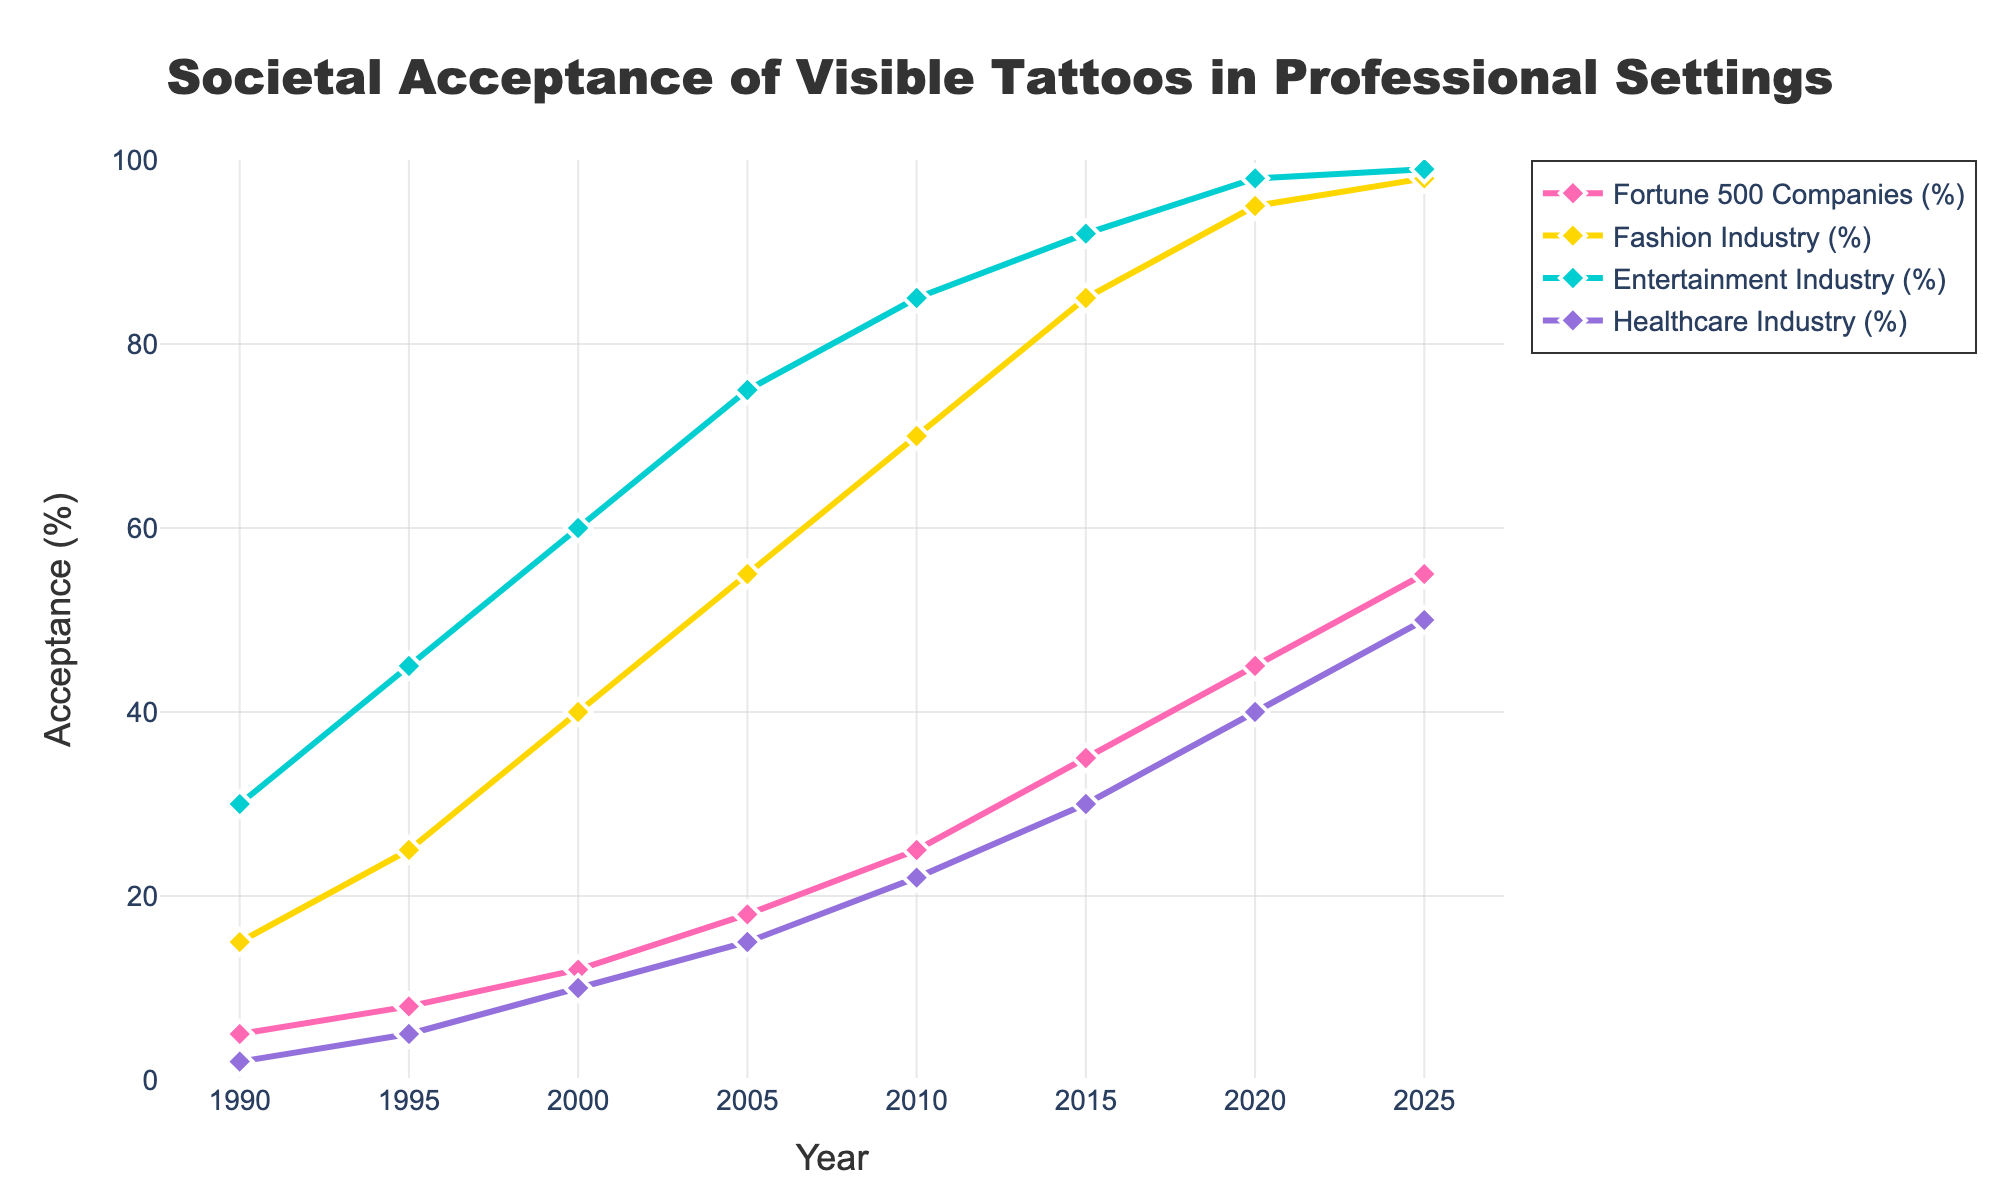what percentage of Fortune 500 companies accepted visible tattoos in 2005? According to the figure, the percentage of Fortune 500 companies accepting visible tattoos in 2005 can be read directly from the data point on the curve corresponding to that year.
Answer: 18% How much did the acceptance of visible tattoos in the entertainment industry increase from 1990 to 2025? To determine the increase, subtract the percentage in 1990 from that in 2025 for the Entertainment Industry curve. Calculation: 99% (2025) - 30% (1990) = 69%
Answer: 69% Which industry had the highest acceptance of visible tattoos in 2015? By comparing the data points for different industries in 2015, we see that the Fashion Industry has the highest acceptance at 85%.
Answer: Fashion Industry In which year did healthcare industry's acceptance rate surpass 30%? Locate the point on the Healthcare Industry curve where the percentage first exceeds 30%. In this case, it happens in 2015.
Answer: 2015 What is the average acceptance percentage of visible tattoos in the Healthcare Industry from 1990 to 2025? Sum the acceptance percentages for all years and divide by the number of years. Calculation: (2 + 5 + 10 + 15 + 22 + 30 + 40 + 50) / 8 = 21.75%
Answer: 21.75% Comparing the Fortune 500 Companies and Fashion Industry, which had a greater acceptance rate increase between 2000 and 2010? Calculate the increase for both: Fortune 500 Companies: 25% (2010) - 12% (2000) = 13% increase; Fashion Industry: 70% (2010) - 40% (2000) = 30% increase.
Answer: Fashion Industry By how much did the acceptance of visible tattoos in the fashion industry surpass that in the healthcare industry in 2020? Subtract the Healthcare Industry's acceptance percentage from the Fashion Industry's in the year 2020. Calculation: 95% - 40% = 55%
Answer: 55% Which industry demonstrated more than a 50% increase in societal acceptance of visible tattoos between 1990 and 2020? By inspecting the curves, the Healthcare Industry (38% increase), Fashion Industry (80% increase), and Entertainment Industry (68% increase) all demonstrate more than a 50% increase.
Answer: Healthcare, Fashion, and Entertainment Describe the trend of tattoo acceptance in the Fortune 500 companies from 1990 to 2025. The trend shows a steady and progressive increase in the acceptance of visible tattoos over the years, starting from 5% in 1990 and reaching 55% in 2025.
Answer: Progressive Increase In which year did the Fashion Industry first reach a 50% acceptance rate? Check the year on the Fashion Industry curve where it first touches or exceeds 50% acceptance. This occurs in the year 2005.
Answer: 2005 